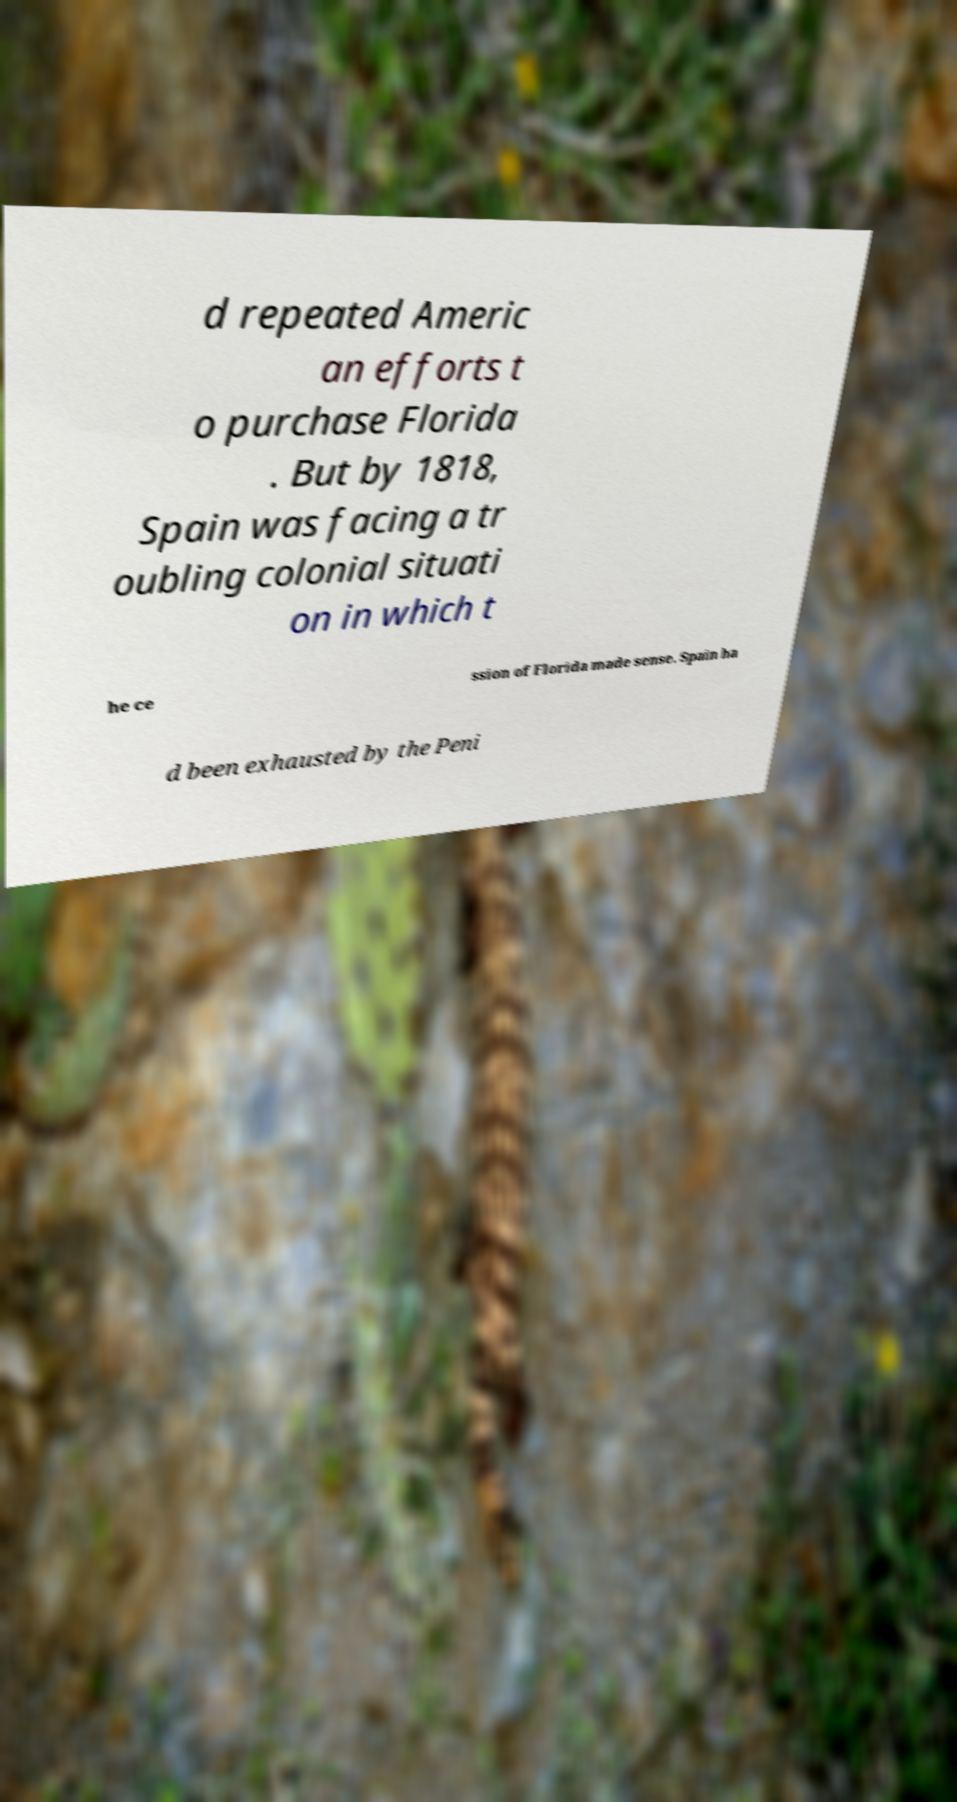Can you accurately transcribe the text from the provided image for me? d repeated Americ an efforts t o purchase Florida . But by 1818, Spain was facing a tr oubling colonial situati on in which t he ce ssion of Florida made sense. Spain ha d been exhausted by the Peni 